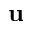<formula> <loc_0><loc_0><loc_500><loc_500>u</formula> 